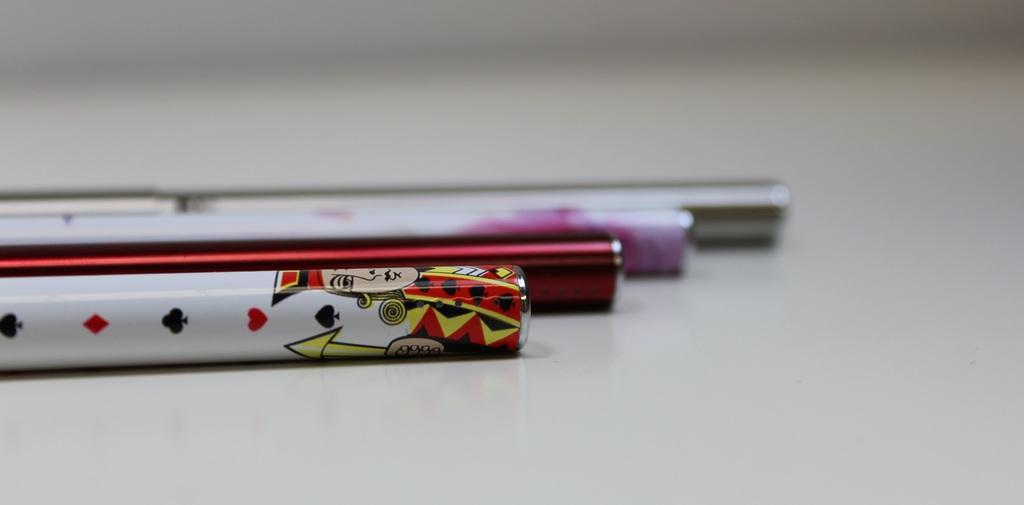Please provide a concise description of this image. In this picture I can see few things in front and I see the cartoon character on the first thing and these all things are on the white color surface. 